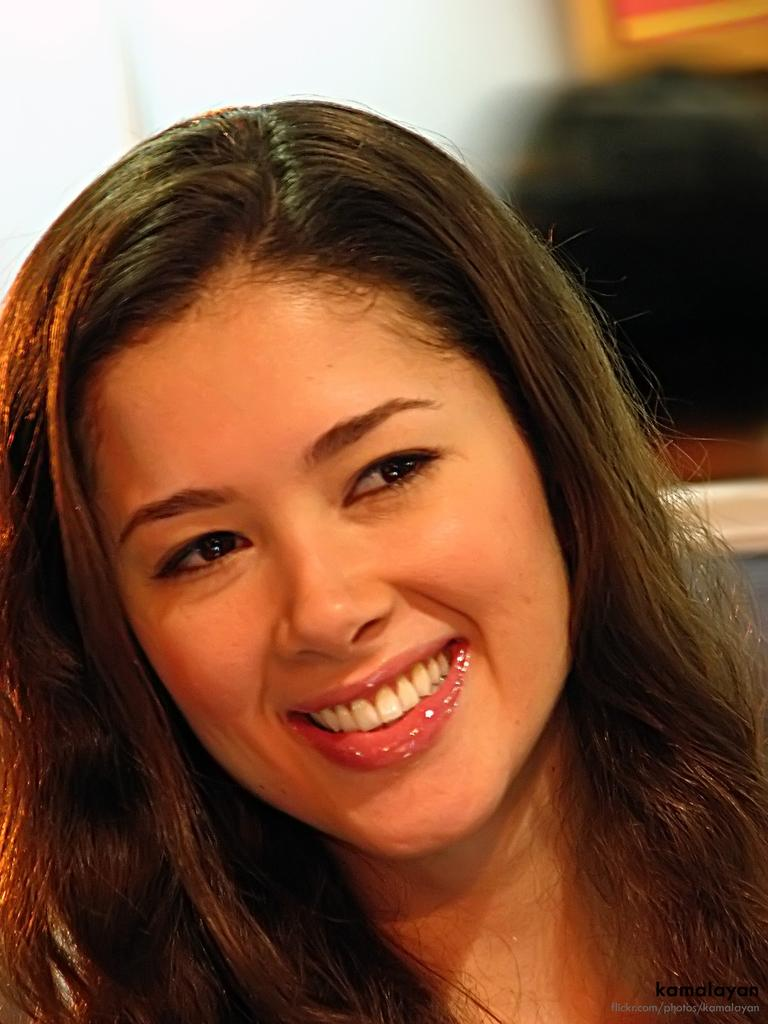What is the main subject in the foreground of the image? There is a woman in the foreground of the image. What is the woman's expression in the image? The woman is smiling in the image. What can be seen in the background of the image? There are objects in the background of the image. What type of roof can be seen in the image? There is no roof visible in the image; it only shows a woman in the foreground and objects in the background. 